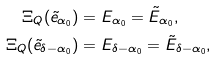<formula> <loc_0><loc_0><loc_500><loc_500>\Xi _ { Q } ( \tilde { e } _ { \alpha _ { 0 } } ) & = E _ { \alpha _ { 0 } } = \tilde { E } _ { \alpha _ { 0 } } , \\ \Xi _ { Q } ( \tilde { e } _ { \delta - \alpha _ { 0 } } ) & = E _ { \delta - \alpha _ { 0 } } = \tilde { E } _ { \delta - \alpha _ { 0 } } ,</formula> 